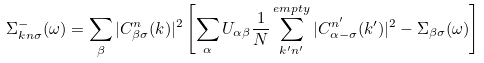Convert formula to latex. <formula><loc_0><loc_0><loc_500><loc_500>\Sigma ^ { - } _ { { k } n \sigma } ( \omega ) = \sum _ { \beta } | C ^ { n } _ { \beta \sigma } ( { k } ) | ^ { 2 } \left [ \sum _ { \alpha } U _ { \alpha \beta } \frac { 1 } { N } \sum ^ { e m p t y } _ { k ^ { \prime } n ^ { \prime } } | C ^ { n ^ { \prime } } _ { \alpha - \sigma } ( { k ^ { \prime } } ) | ^ { 2 } - \Sigma _ { \beta \sigma } ( \omega ) \right ]</formula> 